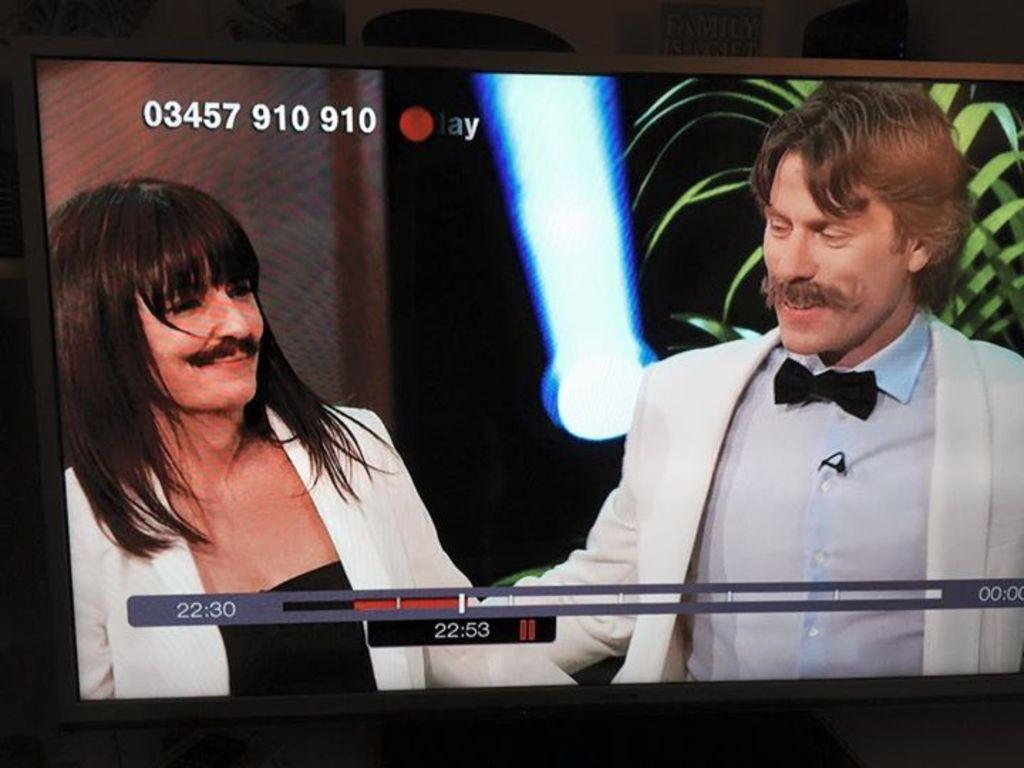How many people are in the image? There are two people in the image. What are the people wearing? The people are wearing suits. What facial feature do the people have in common? The people have mustaches. What can be seen providing illumination in the image? There is a light in the image. What type of vegetation is present in the image? There is a plant in the image. What type of trains can be seen in the image? There are no trains present in the image. On what type of throne are the people sitting in the image? There is no throne present in the image; the people are standing. 